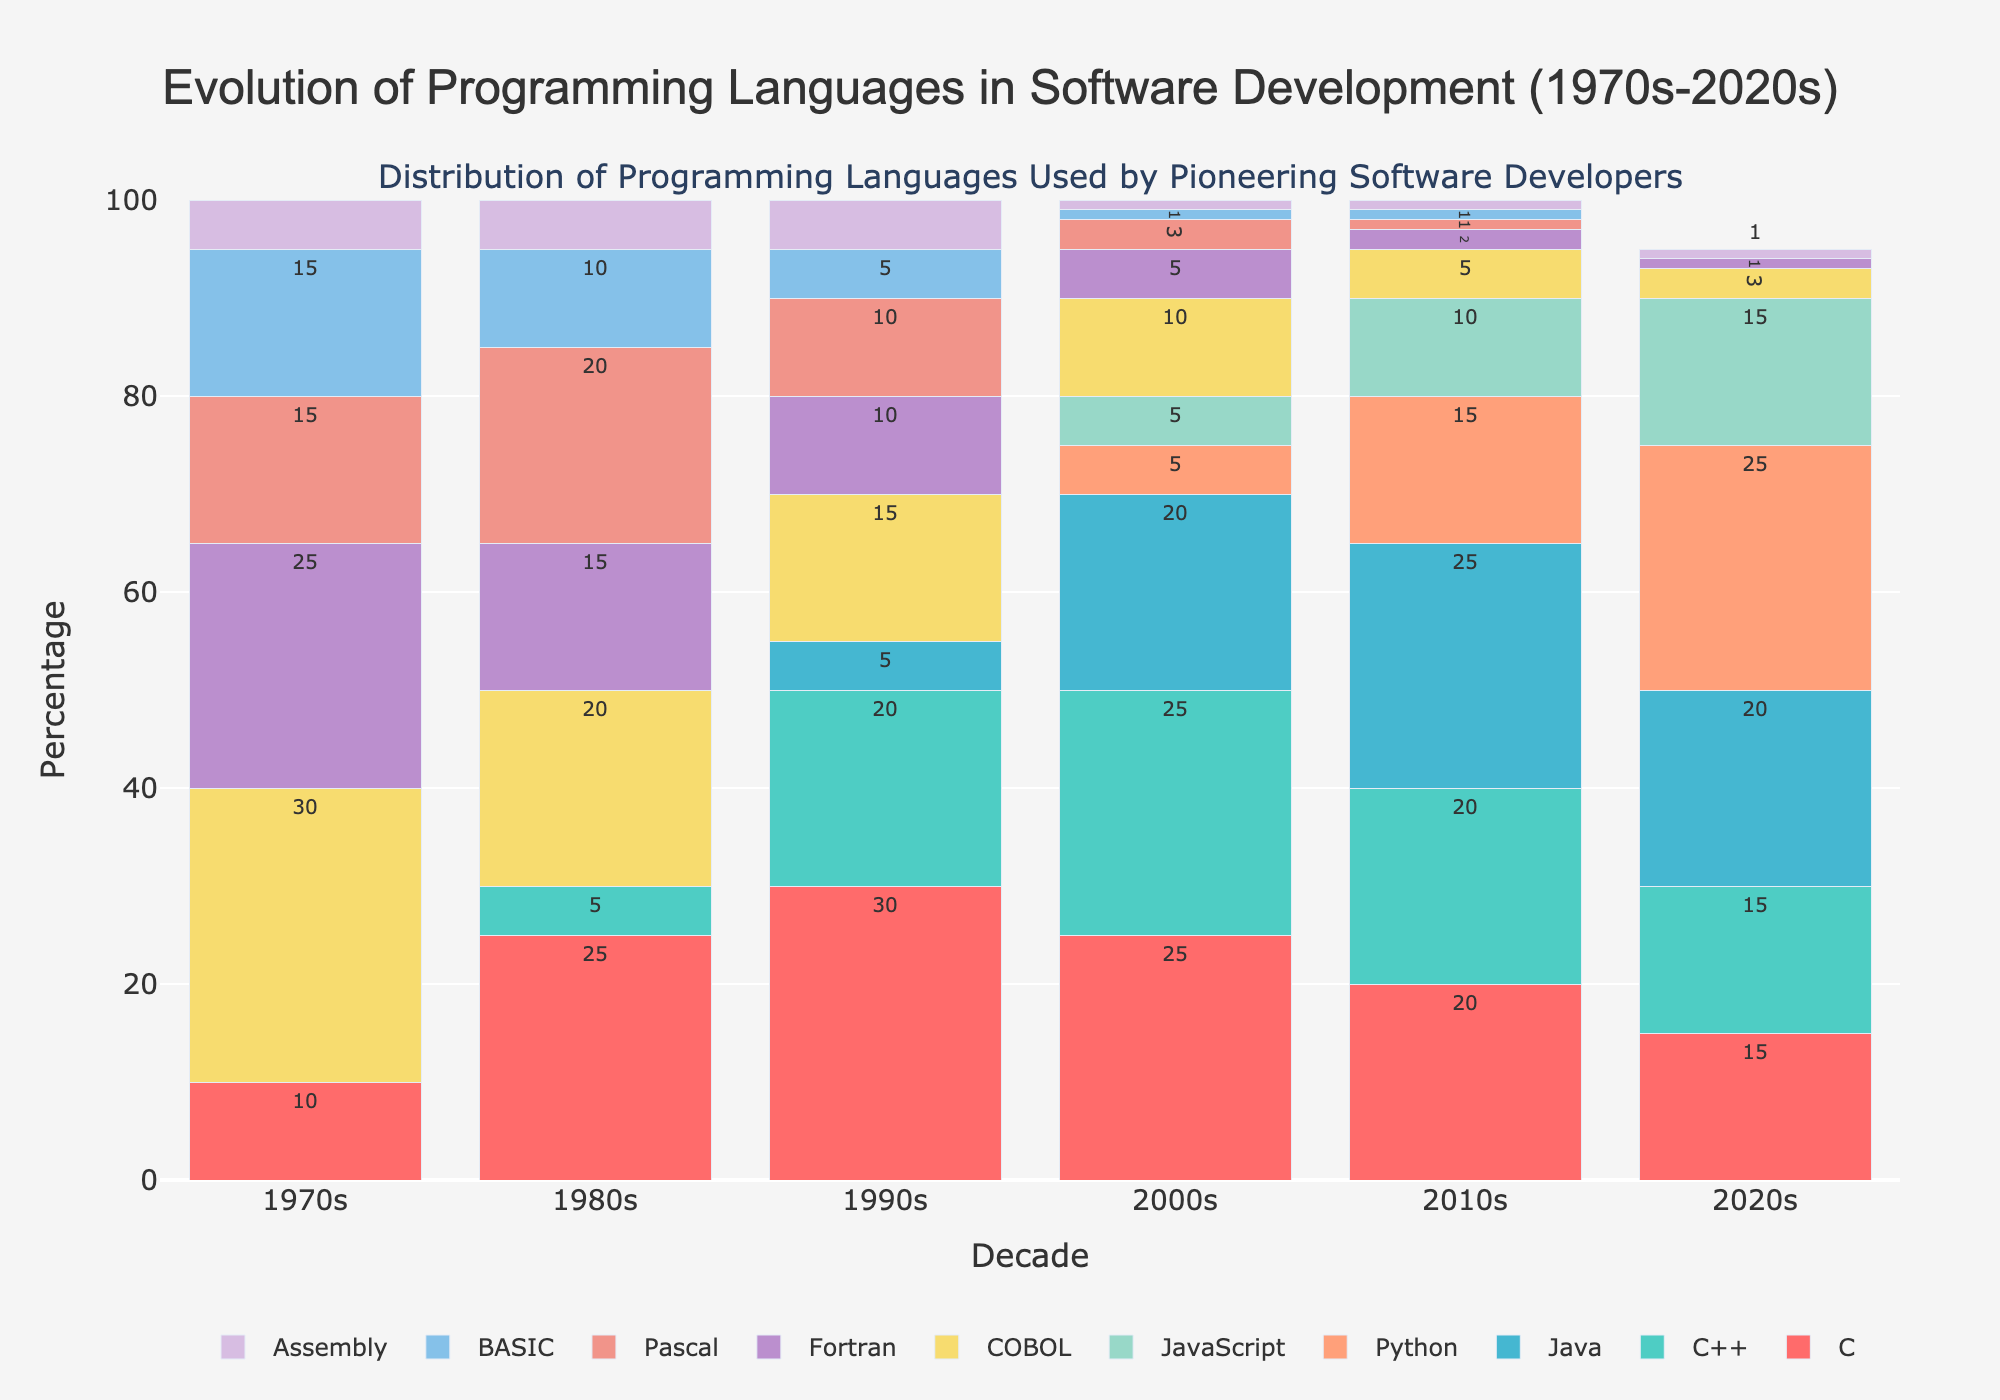Which decade had the highest percentage of COBOL users? Observe the bars corresponding to COBOL for all the decades shown in the chart. The tallest bar represents the highest percentage.
Answer: 1970s How did the percentage of Python usage change from the 2000s to the 2020s? Compare the height of the Python bars for the 2000s and the 2020s. The Python bar in the 2000s is shorter (5%) compared to the bar in the 2020s (25%).
Answer: Increased by 20% Which programming language had the most significant increase in usage from the 1990s to the 2010s? Compare the bars from the 1990s to the 2010s for each language. Identify the language with the largest increase in height.
Answer: Java In which decade did BASIC usage begin to decline? Inspect the bars corresponding to BASIC across the decades and find the decade where the height starts to reduce significantly.
Answer: 1980s Which two decades show the closest percentage usage of C? Observe and measure the heights of the C bars across decades. The decades showing bars of almost equal height are the ones with closest percentage usage.
Answer: 2000s and 2010s What is the total percentage contribution of Fortran across all decades? Add the heights of the Fortran bars across the 1970s, 1980s, 1990s, 2000s, 2010s, and 2020s: 25+15+10+5+2+1.
Answer: 58 Compare the usage of Assembly in the 1970s and 2020s. In which decade was its usage higher? Compare the Assembly bar heights for the 1970s and 2020s. The height difference indicates which decade had higher usage.
Answer: 1970s Calculate the average percentage of Java usage in all decades. Sum the heights of the Java bars from 1990s to 2020s and divide by the number of decades (5): (5 + 20 + 25 + 20)/ 5.
Answer: 14 Did the percentage of JavaScript users surpass Java at any point? Compare the height of the JavaScript and Java bars in each decade. Check if any JavaScript bar is taller than the corresponding Java bar.
Answer: No 